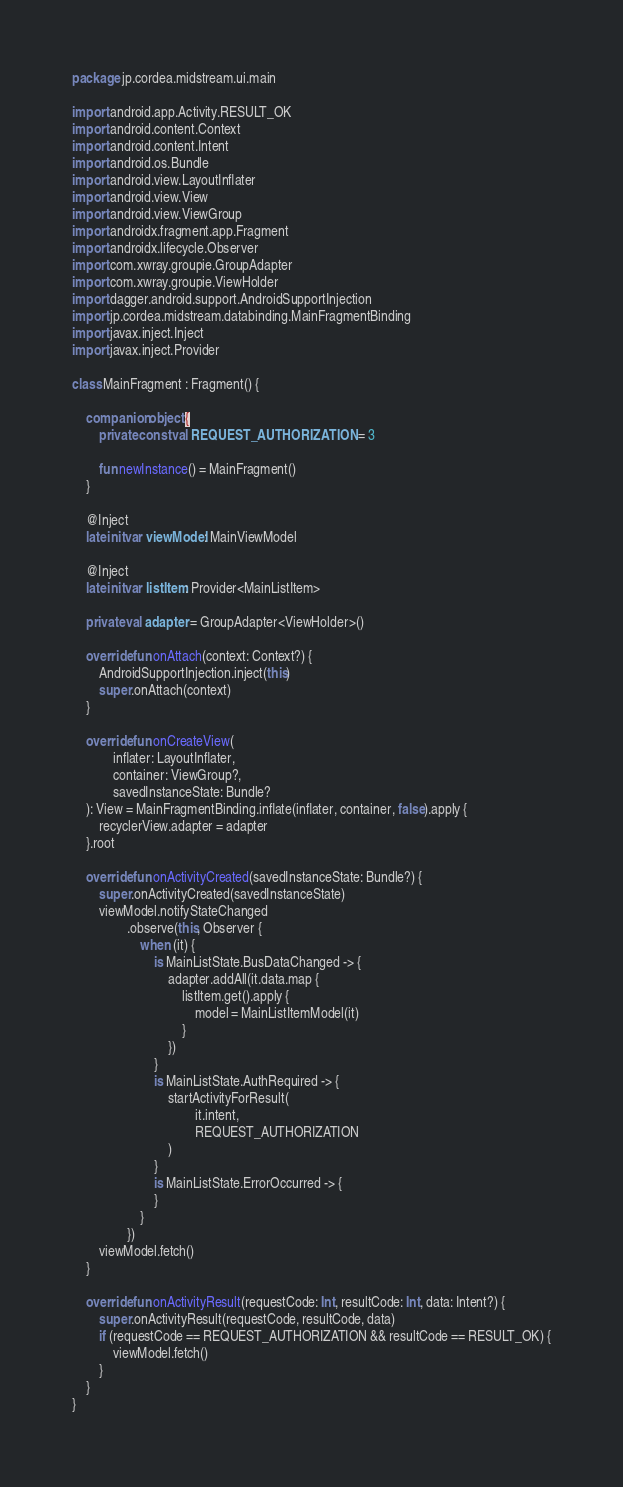<code> <loc_0><loc_0><loc_500><loc_500><_Kotlin_>package jp.cordea.midstream.ui.main

import android.app.Activity.RESULT_OK
import android.content.Context
import android.content.Intent
import android.os.Bundle
import android.view.LayoutInflater
import android.view.View
import android.view.ViewGroup
import androidx.fragment.app.Fragment
import androidx.lifecycle.Observer
import com.xwray.groupie.GroupAdapter
import com.xwray.groupie.ViewHolder
import dagger.android.support.AndroidSupportInjection
import jp.cordea.midstream.databinding.MainFragmentBinding
import javax.inject.Inject
import javax.inject.Provider

class MainFragment : Fragment() {

    companion object {
        private const val REQUEST_AUTHORIZATION = 3

        fun newInstance() = MainFragment()
    }

    @Inject
    lateinit var viewModel: MainViewModel

    @Inject
    lateinit var listItem: Provider<MainListItem>

    private val adapter = GroupAdapter<ViewHolder>()

    override fun onAttach(context: Context?) {
        AndroidSupportInjection.inject(this)
        super.onAttach(context)
    }

    override fun onCreateView(
            inflater: LayoutInflater,
            container: ViewGroup?,
            savedInstanceState: Bundle?
    ): View = MainFragmentBinding.inflate(inflater, container, false).apply {
        recyclerView.adapter = adapter
    }.root

    override fun onActivityCreated(savedInstanceState: Bundle?) {
        super.onActivityCreated(savedInstanceState)
        viewModel.notifyStateChanged
                .observe(this, Observer {
                    when (it) {
                        is MainListState.BusDataChanged -> {
                            adapter.addAll(it.data.map {
                                listItem.get().apply {
                                    model = MainListItemModel(it)
                                }
                            })
                        }
                        is MainListState.AuthRequired -> {
                            startActivityForResult(
                                    it.intent,
                                    REQUEST_AUTHORIZATION
                            )
                        }
                        is MainListState.ErrorOccurred -> {
                        }
                    }
                })
        viewModel.fetch()
    }

    override fun onActivityResult(requestCode: Int, resultCode: Int, data: Intent?) {
        super.onActivityResult(requestCode, resultCode, data)
        if (requestCode == REQUEST_AUTHORIZATION && resultCode == RESULT_OK) {
            viewModel.fetch()
        }
    }
}
</code> 